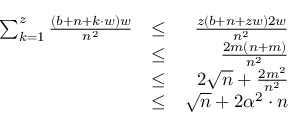Convert formula to latex. <formula><loc_0><loc_0><loc_500><loc_500>\begin{array} { r l r } { \sum _ { k = 1 } ^ { z } \frac { ( b + n + k \cdot w ) w } { n ^ { 2 } } } & { \leq } & { \frac { z ( b + n + z w ) 2 w } { n ^ { 2 } } } \\ & { \leq } & { \frac { 2 m ( n + m ) } { n ^ { 2 } } } \\ & { \leq } & { 2 \sqrt { n } + \frac { 2 m ^ { 2 } } { n ^ { 2 } } } \\ & { \leq } & { \sqrt { n } + 2 \alpha ^ { 2 } \cdot n } \end{array}</formula> 